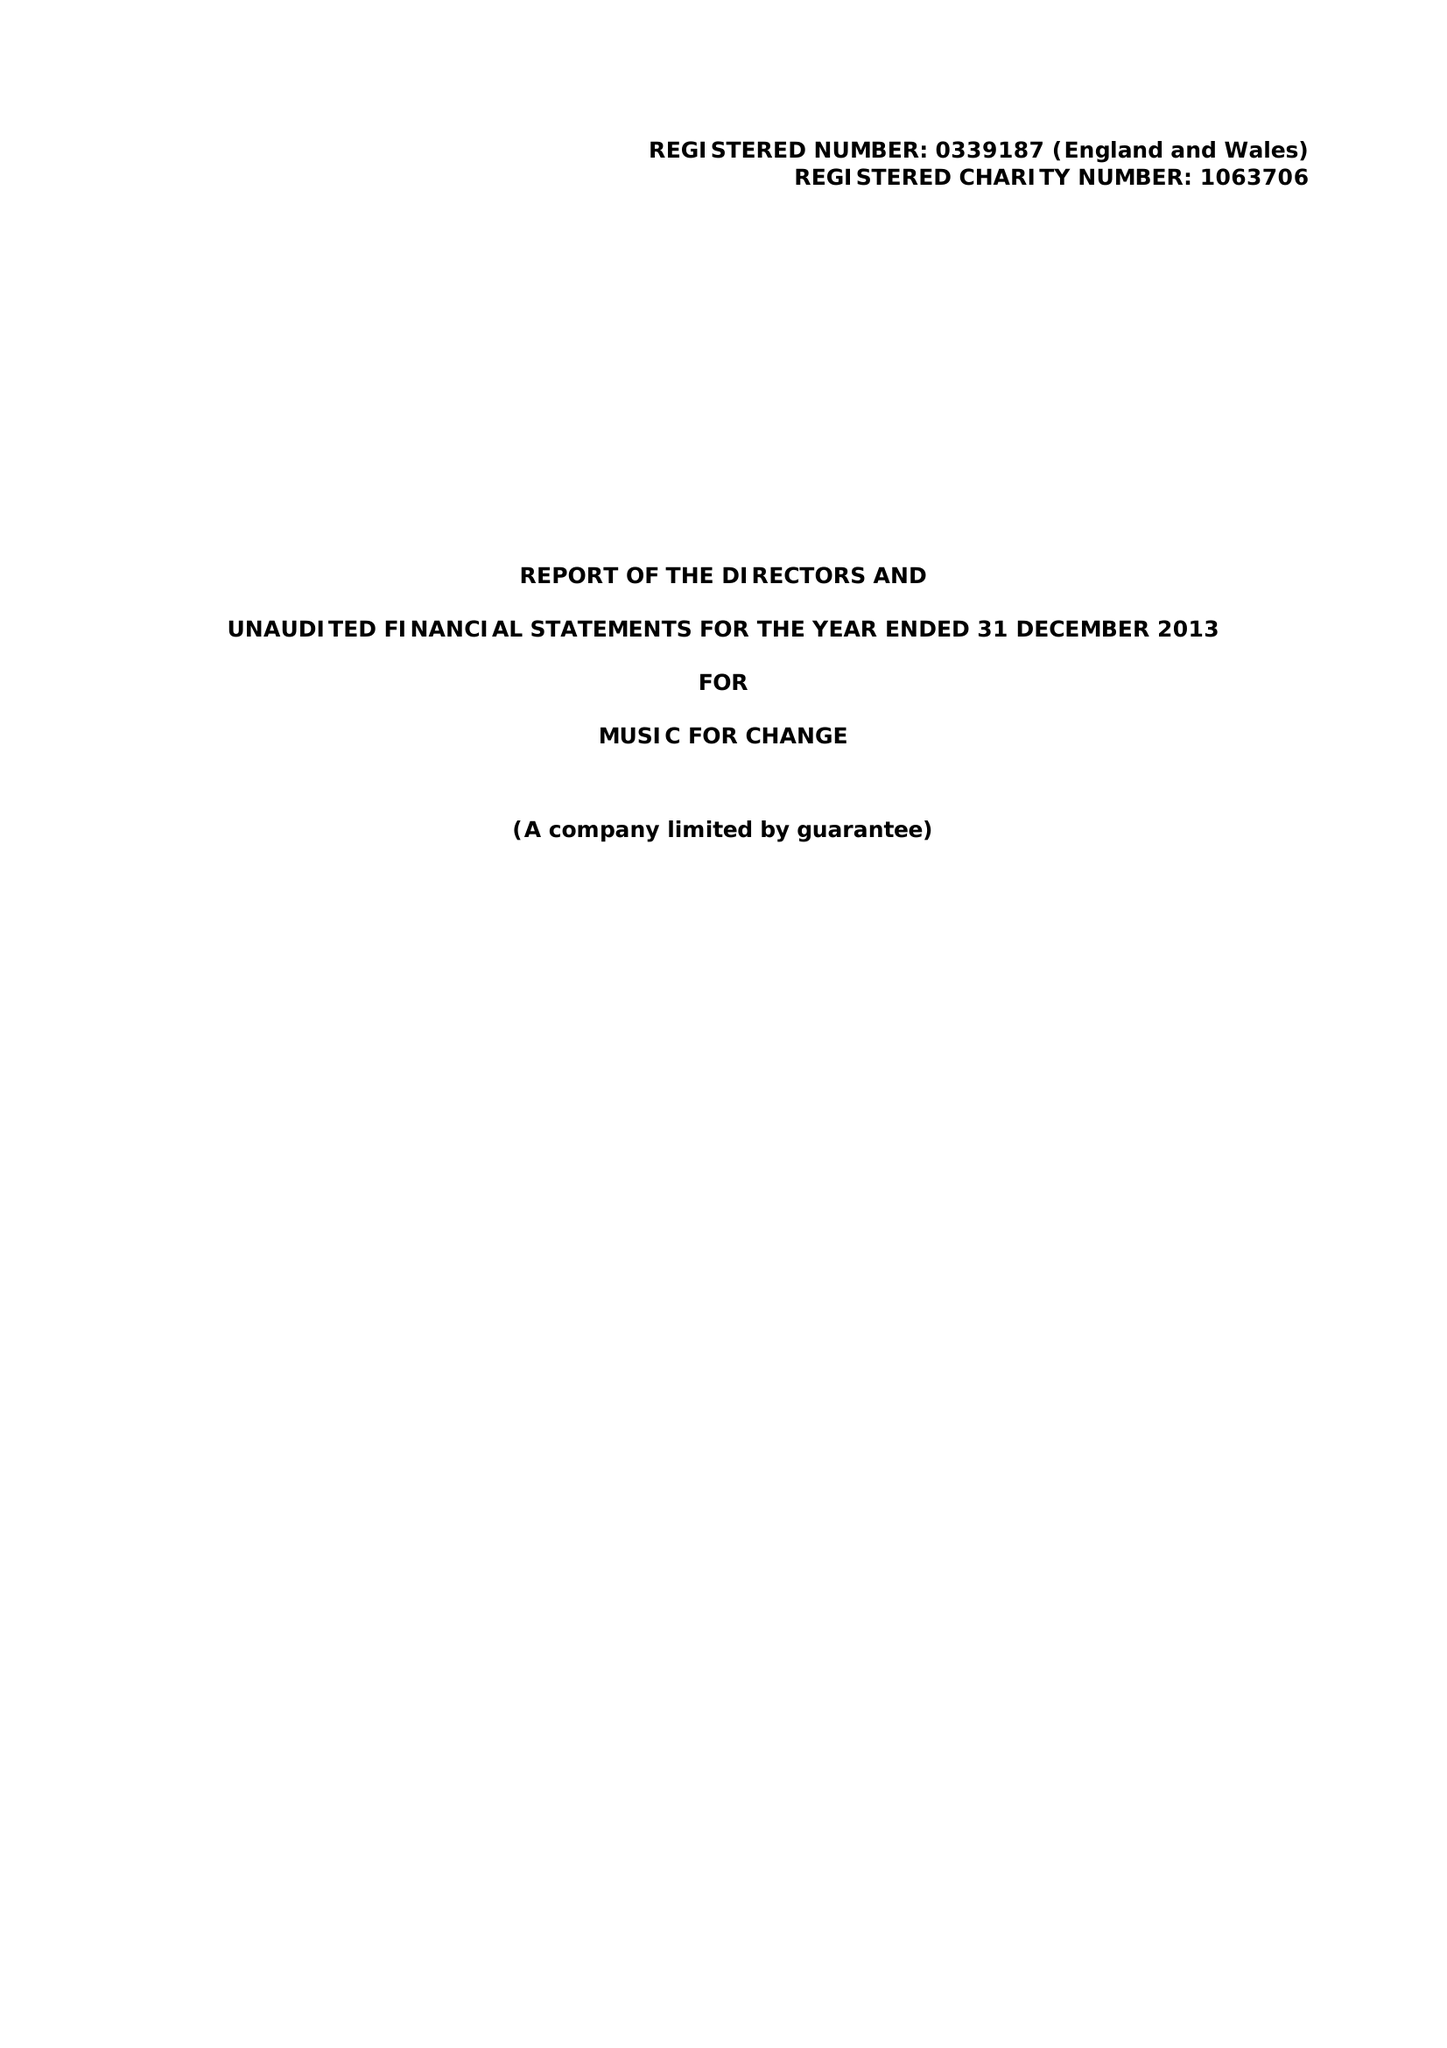What is the value for the charity_number?
Answer the question using a single word or phrase. 1063706 